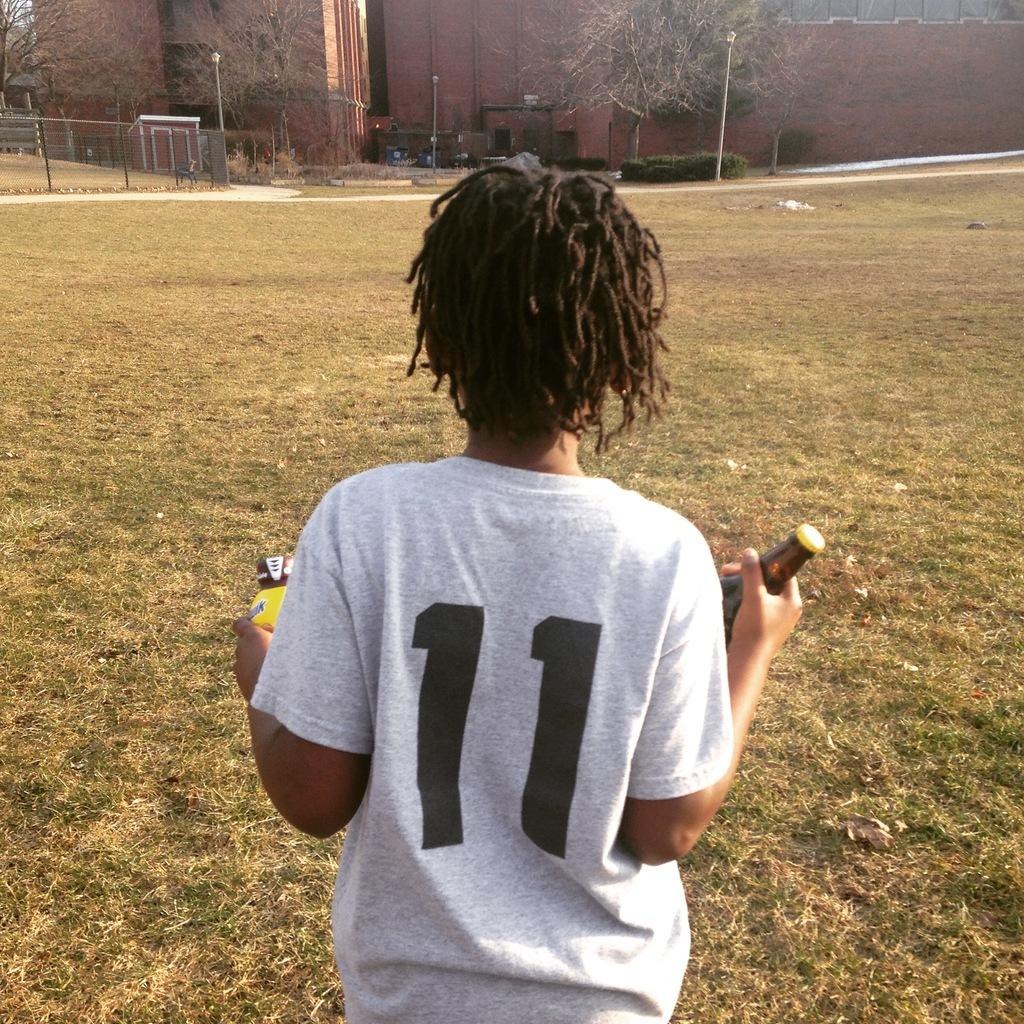<image>
Offer a succinct explanation of the picture presented. A youth athlete wearing number 11 holding Nesquik and a bottle of beer. 